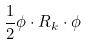Convert formula to latex. <formula><loc_0><loc_0><loc_500><loc_500>\frac { 1 } { 2 } \phi \cdot R _ { k } \cdot \phi</formula> 